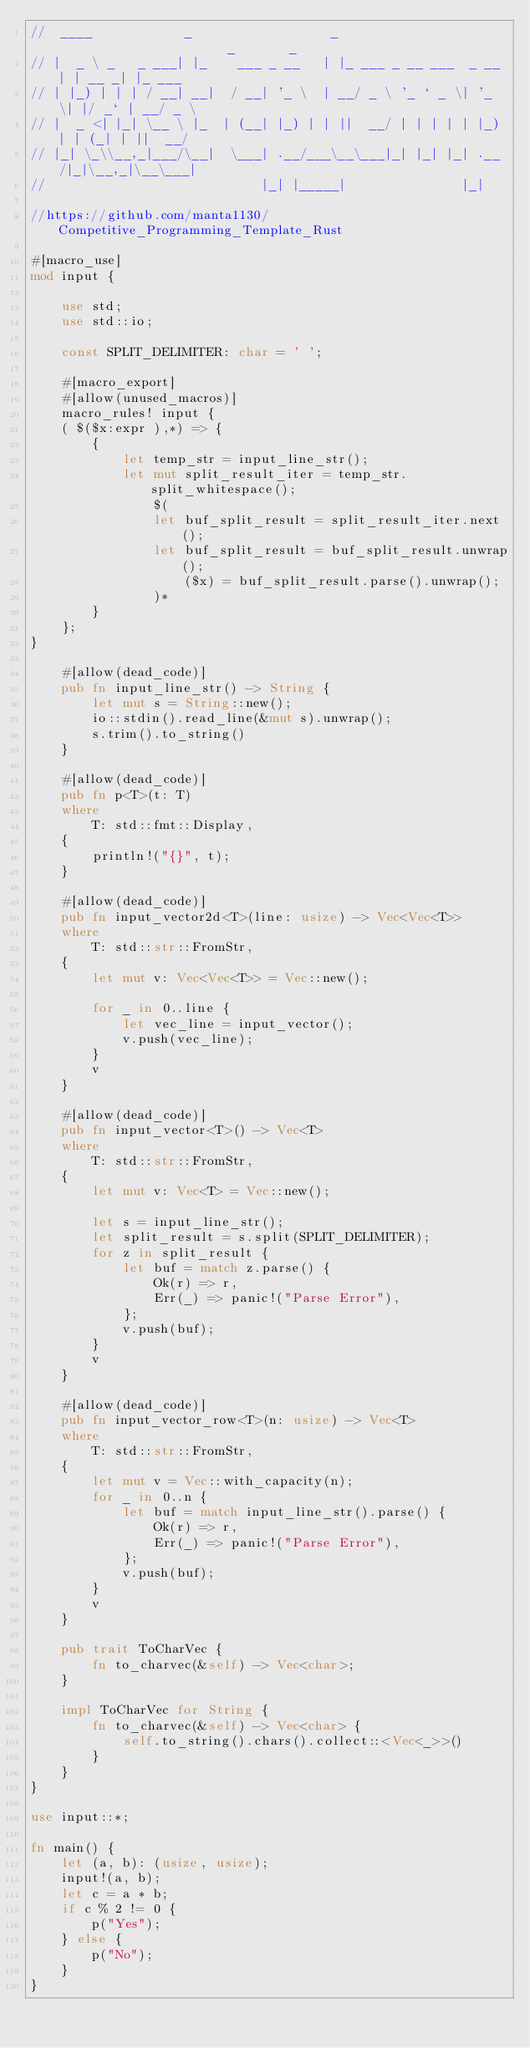<code> <loc_0><loc_0><loc_500><loc_500><_Rust_>//  ____            _                  _                       _       _
// |  _ \ _   _ ___| |_    ___ _ __   | |_ ___ _ __ ___  _ __ | | __ _| |_ ___
// | |_) | | | / __| __|  / __| '_ \  | __/ _ \ '_ ` _ \| '_ \| |/ _` | __/ _ \
// |  _ <| |_| \__ \ |_  | (__| |_) | | ||  __/ | | | | | |_) | | (_| | ||  __/
// |_| \_\\__,_|___/\__|  \___| .__/___\__\___|_| |_| |_| .__/|_|\__,_|\__\___|
//                            |_| |_____|               |_|

//https://github.com/manta1130/Competitive_Programming_Template_Rust

#[macro_use]
mod input {

    use std;
    use std::io;

    const SPLIT_DELIMITER: char = ' ';

    #[macro_export]
    #[allow(unused_macros)]
    macro_rules! input {
    ( $($x:expr ),*) => {
        {
            let temp_str = input_line_str();
            let mut split_result_iter = temp_str.split_whitespace();
                $(
                let buf_split_result = split_result_iter.next();
                let buf_split_result = buf_split_result.unwrap();
                    ($x) = buf_split_result.parse().unwrap();
                )*
        }
    };
}

    #[allow(dead_code)]
    pub fn input_line_str() -> String {
        let mut s = String::new();
        io::stdin().read_line(&mut s).unwrap();
        s.trim().to_string()
    }

    #[allow(dead_code)]
    pub fn p<T>(t: T)
    where
        T: std::fmt::Display,
    {
        println!("{}", t);
    }

    #[allow(dead_code)]
    pub fn input_vector2d<T>(line: usize) -> Vec<Vec<T>>
    where
        T: std::str::FromStr,
    {
        let mut v: Vec<Vec<T>> = Vec::new();

        for _ in 0..line {
            let vec_line = input_vector();
            v.push(vec_line);
        }
        v
    }

    #[allow(dead_code)]
    pub fn input_vector<T>() -> Vec<T>
    where
        T: std::str::FromStr,
    {
        let mut v: Vec<T> = Vec::new();

        let s = input_line_str();
        let split_result = s.split(SPLIT_DELIMITER);
        for z in split_result {
            let buf = match z.parse() {
                Ok(r) => r,
                Err(_) => panic!("Parse Error"),
            };
            v.push(buf);
        }
        v
    }

    #[allow(dead_code)]
    pub fn input_vector_row<T>(n: usize) -> Vec<T>
    where
        T: std::str::FromStr,
    {
        let mut v = Vec::with_capacity(n);
        for _ in 0..n {
            let buf = match input_line_str().parse() {
                Ok(r) => r,
                Err(_) => panic!("Parse Error"),
            };
            v.push(buf);
        }
        v
    }

    pub trait ToCharVec {
        fn to_charvec(&self) -> Vec<char>;
    }

    impl ToCharVec for String {
        fn to_charvec(&self) -> Vec<char> {
            self.to_string().chars().collect::<Vec<_>>()
        }
    }
}

use input::*;

fn main() {
    let (a, b): (usize, usize);
    input!(a, b);
    let c = a * b;
    if c % 2 != 0 {
        p("Yes");
    } else {
        p("No");
    }
}
</code> 